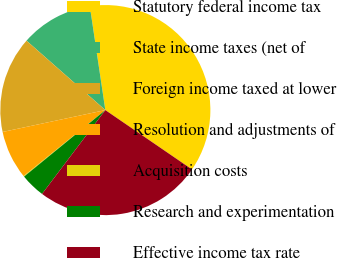<chart> <loc_0><loc_0><loc_500><loc_500><pie_chart><fcel>Statutory federal income tax<fcel>State income taxes (net of<fcel>Foreign income taxed at lower<fcel>Resolution and adjustments of<fcel>Acquisition costs<fcel>Research and experimentation<fcel>Effective income tax rate<nl><fcel>36.92%<fcel>11.15%<fcel>14.83%<fcel>7.47%<fcel>0.11%<fcel>3.79%<fcel>25.74%<nl></chart> 